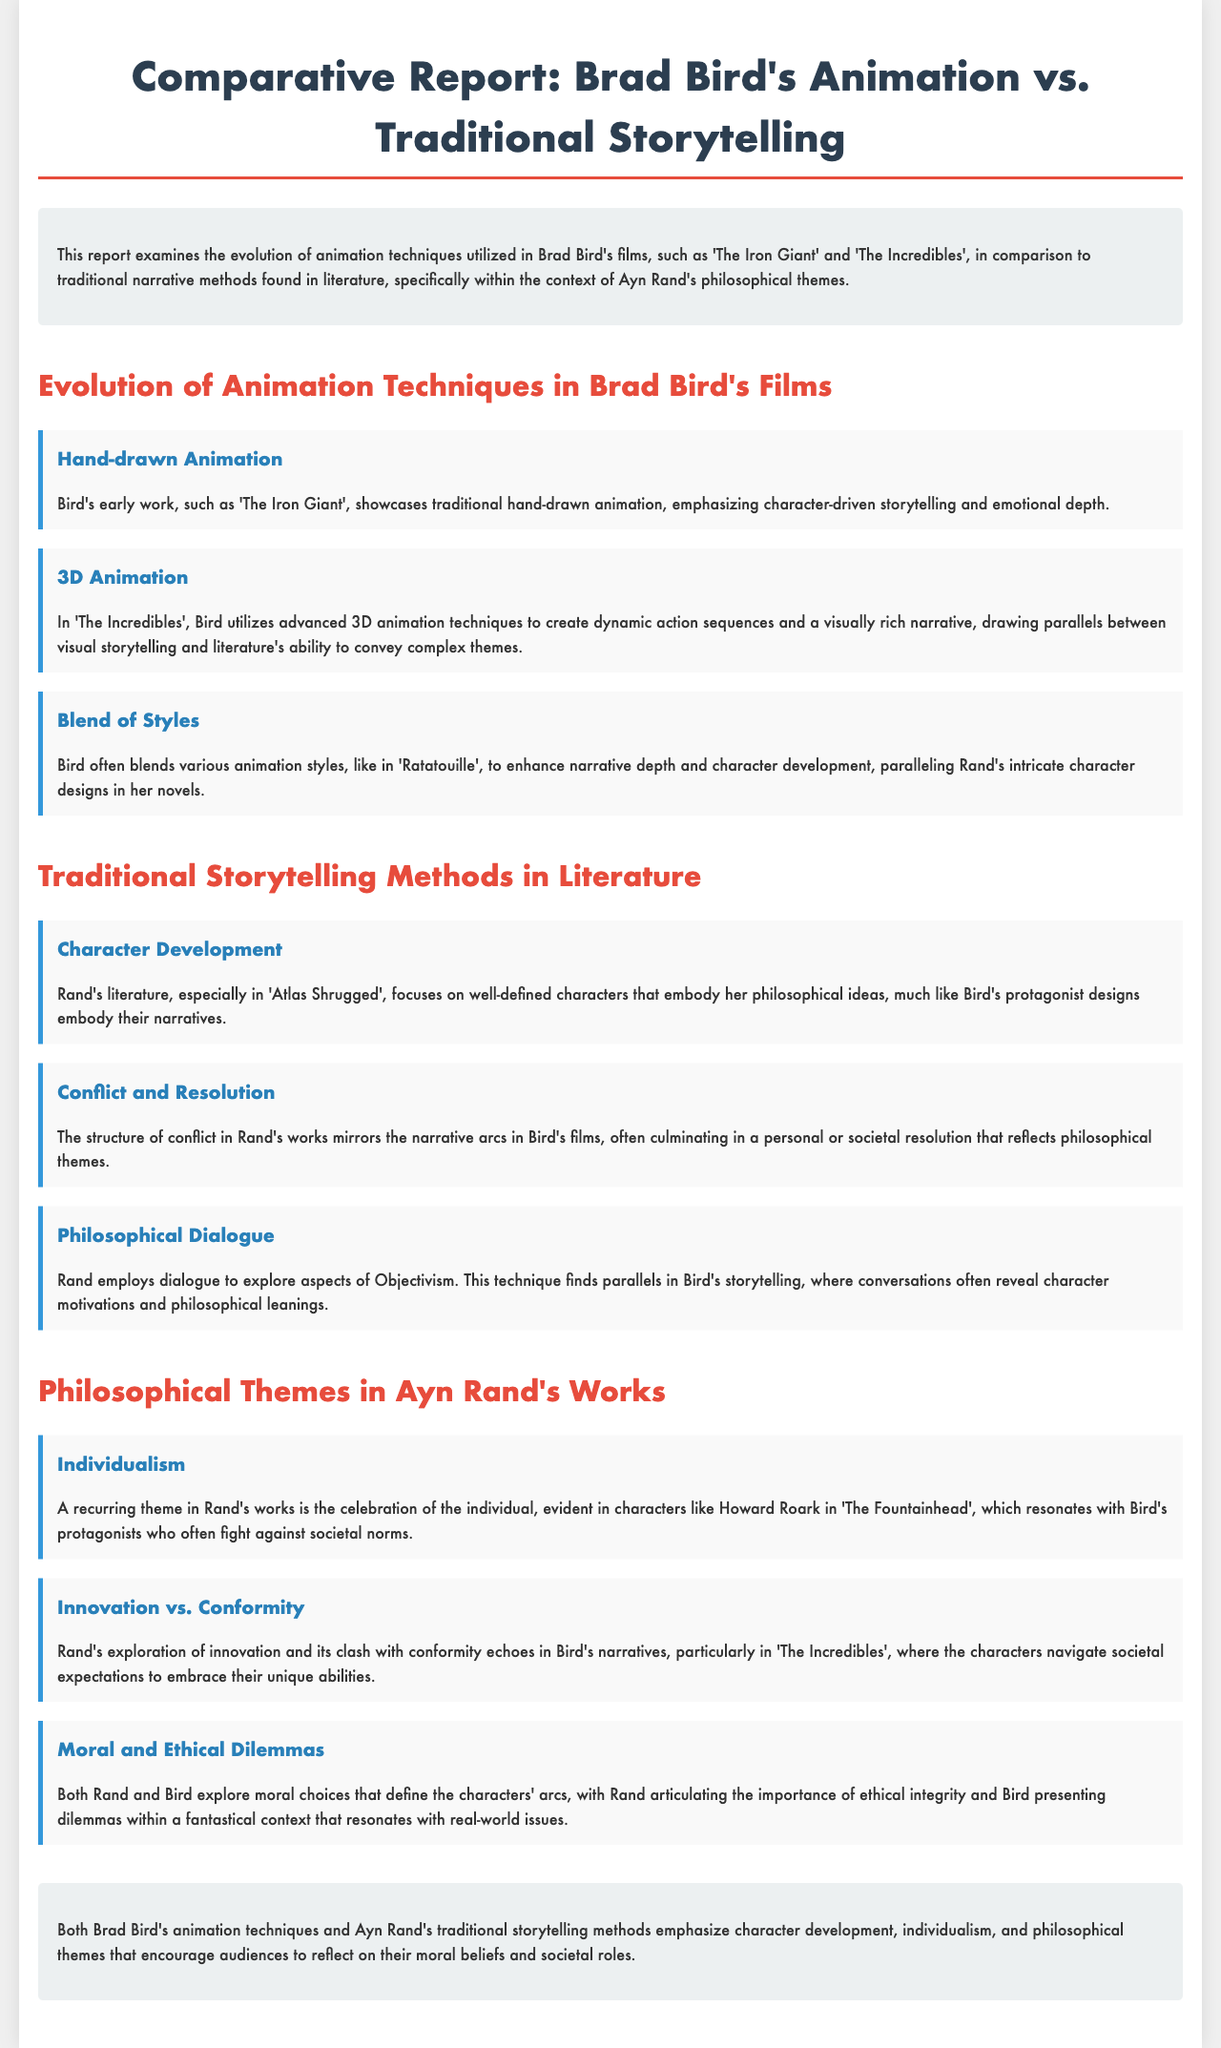What animation technique is showcased in 'The Iron Giant'? The report states that 'The Iron Giant' showcases traditional hand-drawn animation, emphasizing character-driven storytelling and emotional depth.
Answer: Hand-drawn animation What film used advanced 3D animation techniques? The document describes 'The Incredibles' as utilizing advanced 3D animation techniques to create dynamic action sequences and a visually rich narrative.
Answer: The Incredibles Which philosophical theme is related to Howard Roark? The document mentions individualism as a recurring theme in Rand's works, evident in characters like Howard Roark in 'The Fountainhead'.
Answer: Individualism What aspect parallels Rand's intricate character designs? The report states that Bird often blends various animation styles to enhance narrative depth and character development, paralleling Rand's intricate character designs in her novels.
Answer: Animation styles What is a central focus of Rand's literature? The document notes that Rand's literature, especially in 'Atlas Shrugged', focuses on well-defined characters that embody her philosophical ideas.
Answer: Character Development In which film does the theme of innovation vs. conformity appear? The report discusses that the theme of innovation vs. conformity is echoed in Bird's narratives, particularly in 'The Incredibles'.
Answer: The Incredibles What feature of Rand's storytelling is reflected in Bird's films? The report states that both Rand and Bird explore moral choices that define the characters' arcs, indicating a similarity in their storytelling techniques.
Answer: Moral choices What is the primary focus of the report? The report examines the evolution of animation techniques utilized in Brad Bird's films in comparison to traditional narrative methods found in literature.
Answer: Evolution of animation techniques What element enhances Bird's character development? The document mentions that blending various animation styles enhances narrative depth and character development in Bird's films.
Answer: Blending animation styles 